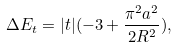<formula> <loc_0><loc_0><loc_500><loc_500>\Delta E _ { t } = | t | ( - 3 + \frac { \pi ^ { 2 } a ^ { 2 } } { 2 R ^ { 2 } } ) ,</formula> 